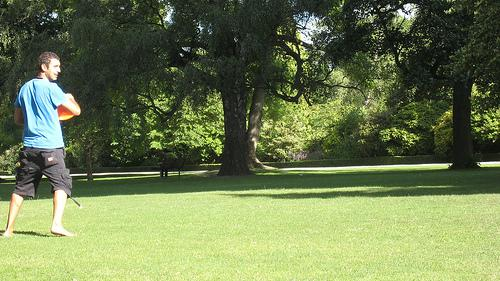Question: what is the color of the frisbee?
Choices:
A. Orange.
B. Red.
C. White.
D. Green.
Answer with the letter. Answer: A Question: where is this man?
Choices:
A. At the park.
B. At the beach.
C. At the store.
D. In a restaurant.
Answer with the letter. Answer: A 